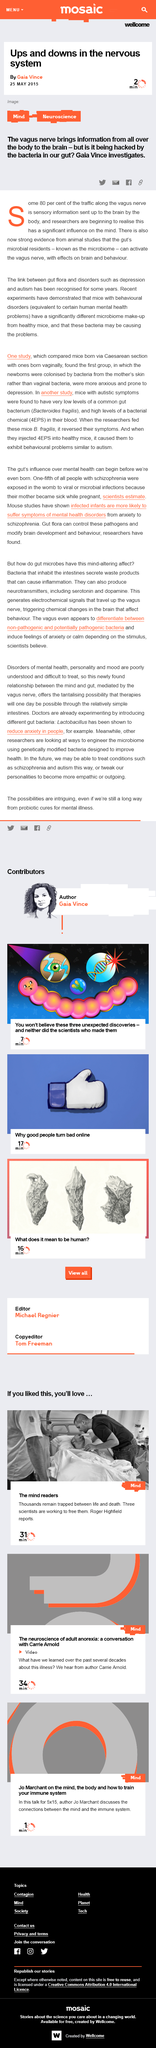Specify some key components in this picture. The vagus nerve is responsible for conveying information from various parts of the body to the brain. The article on ups and downs in the nervous system was written by Gaia Vince. The gut microbiome is a term used to describe the collection of microorganisms that reside in the gut. These microorganisms are known as the gut microbial residents and play an essential role in maintaining the health of the gut. 